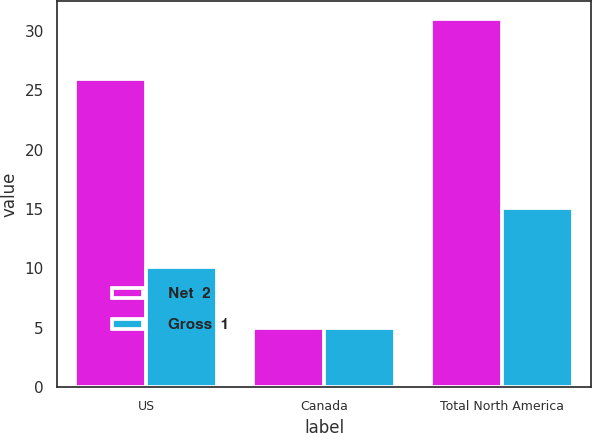<chart> <loc_0><loc_0><loc_500><loc_500><stacked_bar_chart><ecel><fcel>US<fcel>Canada<fcel>Total North America<nl><fcel>Net  2<fcel>26<fcel>5<fcel>31<nl><fcel>Gross  1<fcel>10.1<fcel>5<fcel>15.1<nl></chart> 